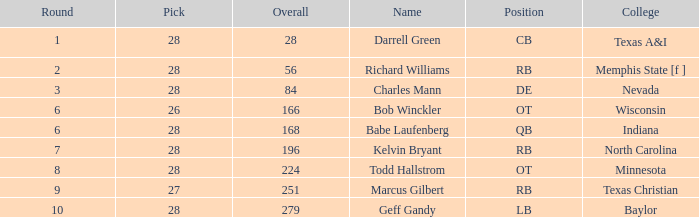What is the maximum draft choice of the player from texas a&i with an overall under 28? None. 